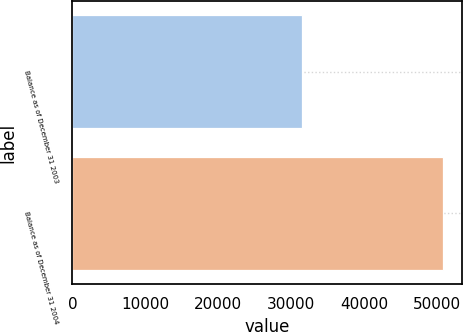Convert chart to OTSL. <chart><loc_0><loc_0><loc_500><loc_500><bar_chart><fcel>Balance as of December 31 2003<fcel>Balance as of December 31 2004<nl><fcel>31468<fcel>50885<nl></chart> 